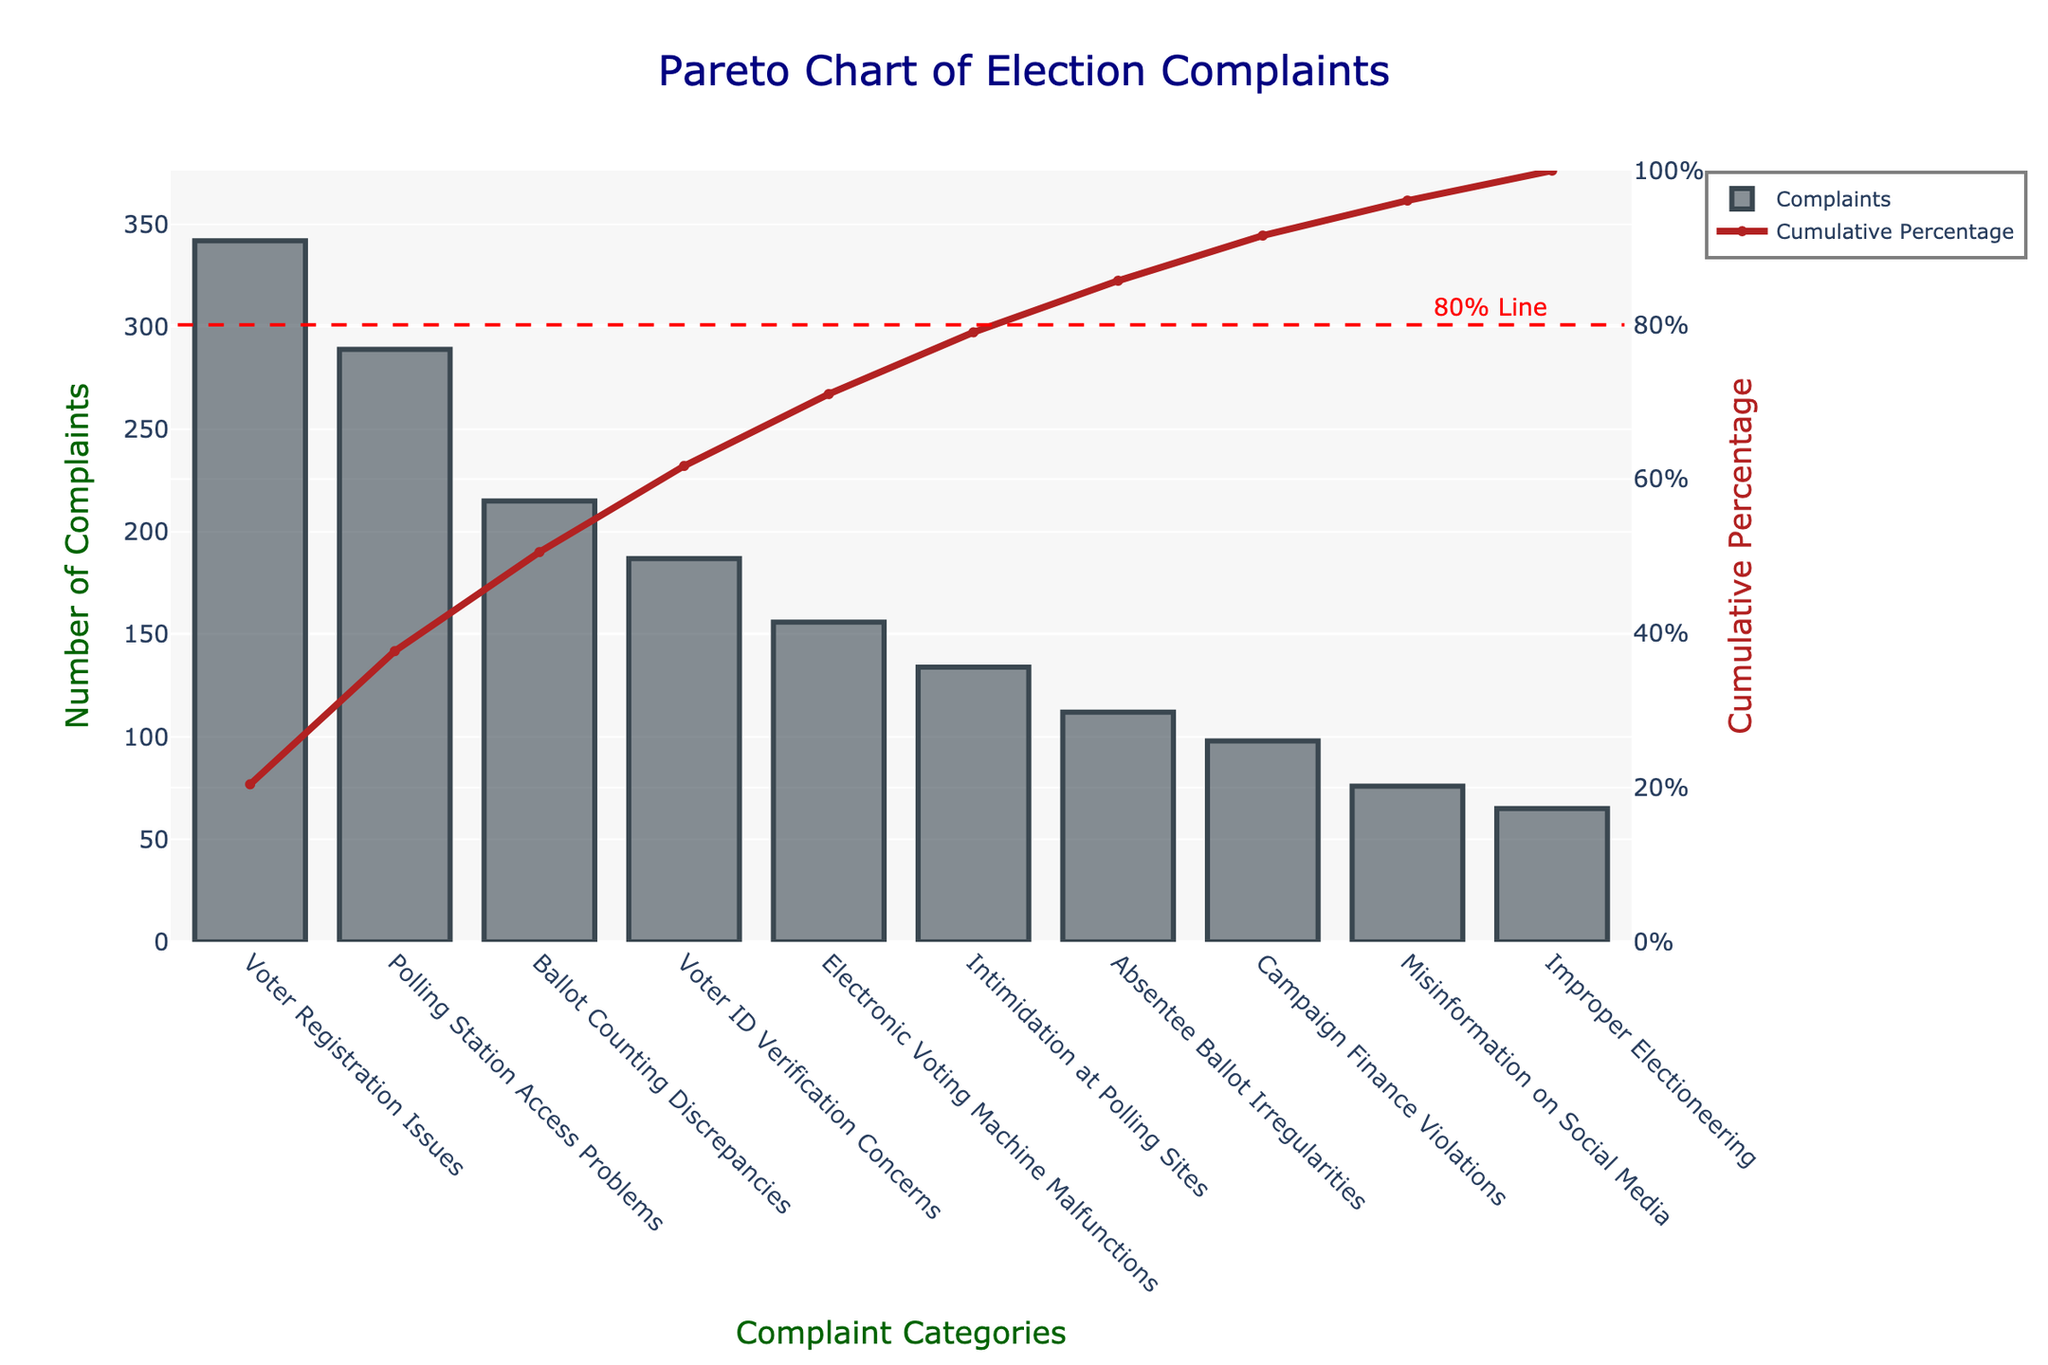What is the title of the chart? The title is displayed at the top center of the chart, indicating the main subject of the visual.
Answer: Pareto Chart of Election Complaints Which category has the highest number of complaints? The first bar in the chart represents the category with the highest number of complaints.
Answer: Voter Registration Issues What is the cumulative percentage of the top three complaint categories? Sum the number of complaints for the top three categories and then calculate the percentage relative to the total number of complaints.
Answer: 56.34% How many complaints were reported regarding 'Electronic Voting Machine Malfunctions'? Locate the bar labeled 'Electronic Voting Machine Malfunctions' on the x-axis and read the corresponding value on the y-axis.
Answer: 156 What cumulative percentage does the first category alone cover? Look at the cumulative percentage line above the highest bar and read the corresponding percentage.
Answer: 19.28% Is 'Ballot Counting Discrepancies' within the top three complaints? Compare the positioning of 'Ballot Counting Discrepancies' with the other bars to determine if it is one of the first three bars.
Answer: Yes What percentage of complaints are covered by the 'Absentee Ballot Irregularities' category? Use the value on the y-axis for 'Absentee Ballot Irregularities' and convert it to a percentage of the total number of complaints.
Answer: 6.31% What is the total number of complaints? Sum all the values of complaints listed for each category.
Answer: 1674 Which category is just above the 80% cumulative percentage line? Identify the category where the cumulative percentage line crosses just above the dashed 80% line.
Answer: Absentee Ballot Irregularities Compare the number of complaints between 'Voter ID Verification Concerns' and 'Misinformation on Social Media'. Look at the heights of the bars for both categories and subtract the number of complaints for 'Misinformation on Social Media' from 'Voter ID Verification Concerns'.
Answer: 111 